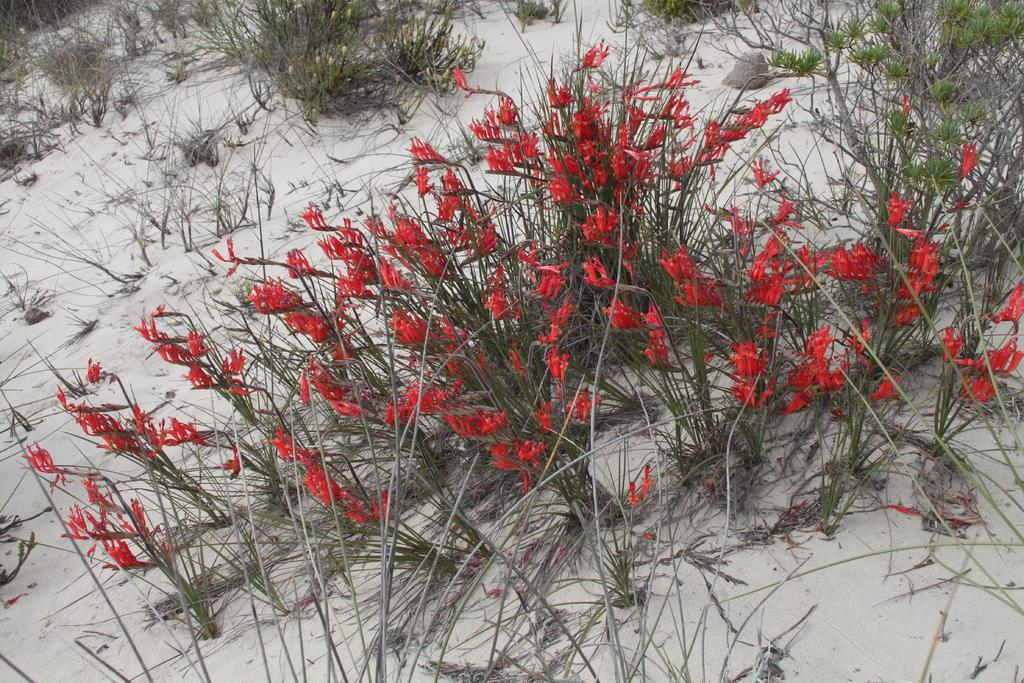What type of flowers can be seen in the image? There are red flowers in the image. What else is present in the image besides the flowers? There are plants in the image. What is the weather or season depicted in the image? The image shows snow, which suggests a cold weather or winter season. Where is the library located in the image? There is no library present in the image. What type of utensil is used to eat the flowers in the image? The flowers are not meant to be eaten, and there are no utensils present in the image. 